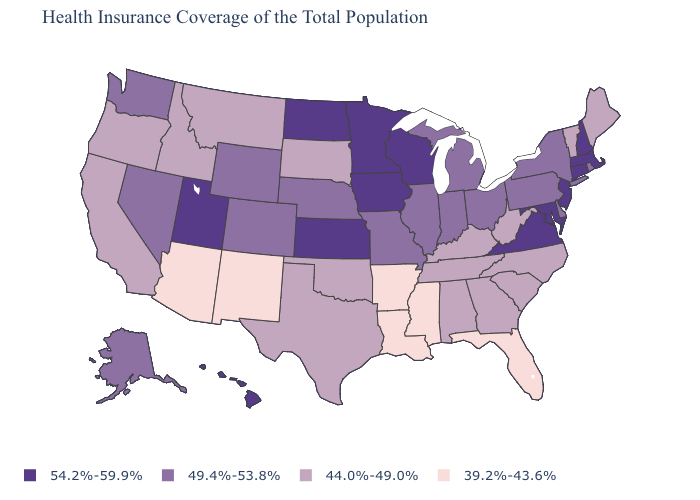Does North Dakota have the highest value in the USA?
Be succinct. Yes. What is the highest value in the USA?
Concise answer only. 54.2%-59.9%. Among the states that border Louisiana , does Texas have the lowest value?
Be succinct. No. What is the value of Indiana?
Write a very short answer. 49.4%-53.8%. Name the states that have a value in the range 49.4%-53.8%?
Write a very short answer. Alaska, Colorado, Delaware, Illinois, Indiana, Michigan, Missouri, Nebraska, Nevada, New York, Ohio, Pennsylvania, Rhode Island, Washington, Wyoming. Name the states that have a value in the range 44.0%-49.0%?
Keep it brief. Alabama, California, Georgia, Idaho, Kentucky, Maine, Montana, North Carolina, Oklahoma, Oregon, South Carolina, South Dakota, Tennessee, Texas, Vermont, West Virginia. Does the first symbol in the legend represent the smallest category?
Give a very brief answer. No. What is the highest value in the West ?
Concise answer only. 54.2%-59.9%. Name the states that have a value in the range 39.2%-43.6%?
Answer briefly. Arizona, Arkansas, Florida, Louisiana, Mississippi, New Mexico. Among the states that border Michigan , does Ohio have the lowest value?
Write a very short answer. Yes. Which states have the lowest value in the USA?
Short answer required. Arizona, Arkansas, Florida, Louisiana, Mississippi, New Mexico. Name the states that have a value in the range 49.4%-53.8%?
Quick response, please. Alaska, Colorado, Delaware, Illinois, Indiana, Michigan, Missouri, Nebraska, Nevada, New York, Ohio, Pennsylvania, Rhode Island, Washington, Wyoming. What is the value of Oregon?
Concise answer only. 44.0%-49.0%. Among the states that border Mississippi , which have the lowest value?
Keep it brief. Arkansas, Louisiana. Name the states that have a value in the range 49.4%-53.8%?
Concise answer only. Alaska, Colorado, Delaware, Illinois, Indiana, Michigan, Missouri, Nebraska, Nevada, New York, Ohio, Pennsylvania, Rhode Island, Washington, Wyoming. 